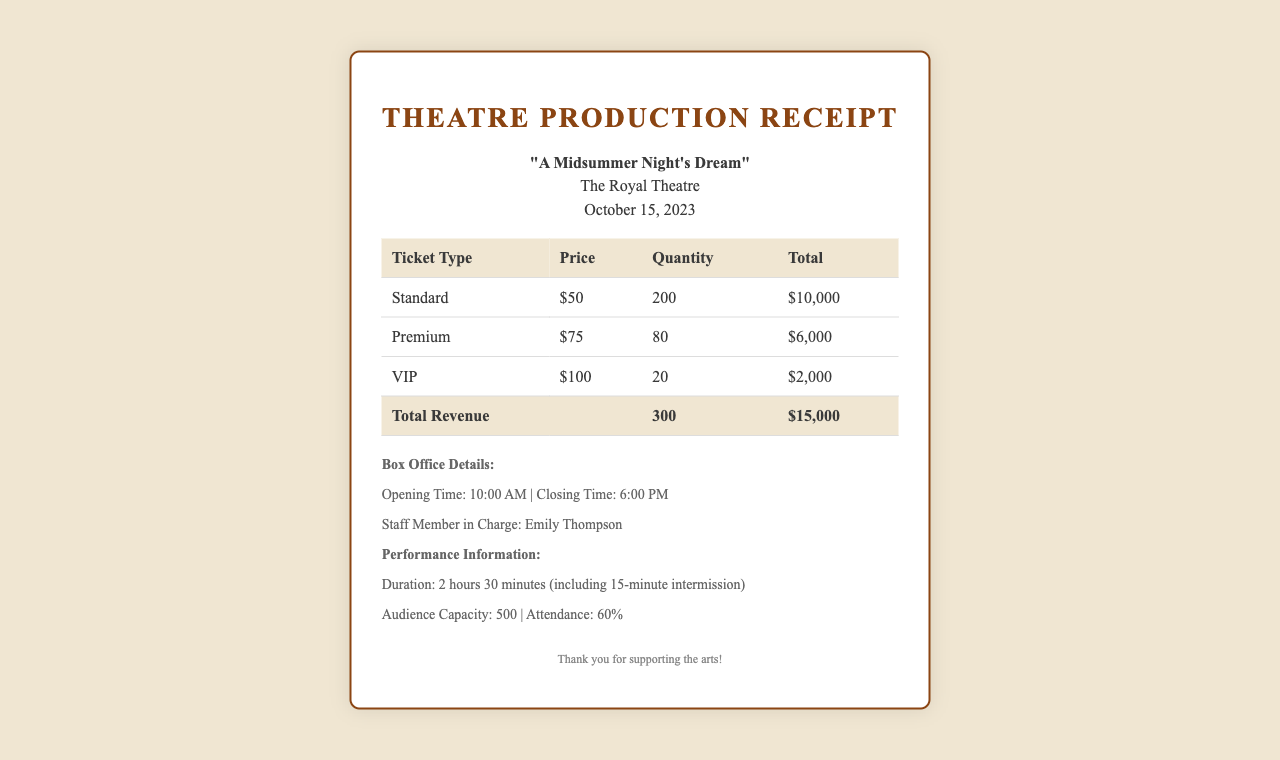What is the title of the production? The title of the production is mentioned at the top of the document under production info.
Answer: "A Midsummer Night's Dream" What is the total revenue generated from ticket sales? The total revenue is calculated by summing the total for each ticket type listed in the table.
Answer: $15,000 How many tickets were sold in total? The total number of tickets sold is listed in the total row of the ticket sales summary.
Answer: 300 What is the price of a Premium ticket? The price for the Premium ticket is shown in the ticket type breakdown.
Answer: $75 How many Standard tickets were sold? The quantity of Standard tickets sold is provided in the ticket breakdown table.
Answer: 200 What was the attendance percentage of the performance? Attendance percentage is mentioned in the performance information section.
Answer: 60% Who was the staff member in charge? The name of the staff member in charge is indicated under box office details.
Answer: Emily Thompson What is the duration of the performance? The duration is specified in the performance information section of the document.
Answer: 2 hours 30 minutes (including 15-minute intermission) What is the opening time of the box office? The opening time is listed in the box office details section.
Answer: 10:00 AM 